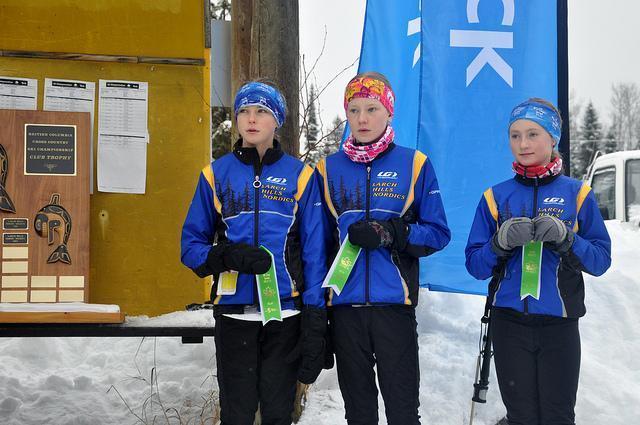How many people are in the photo?
Give a very brief answer. 3. 